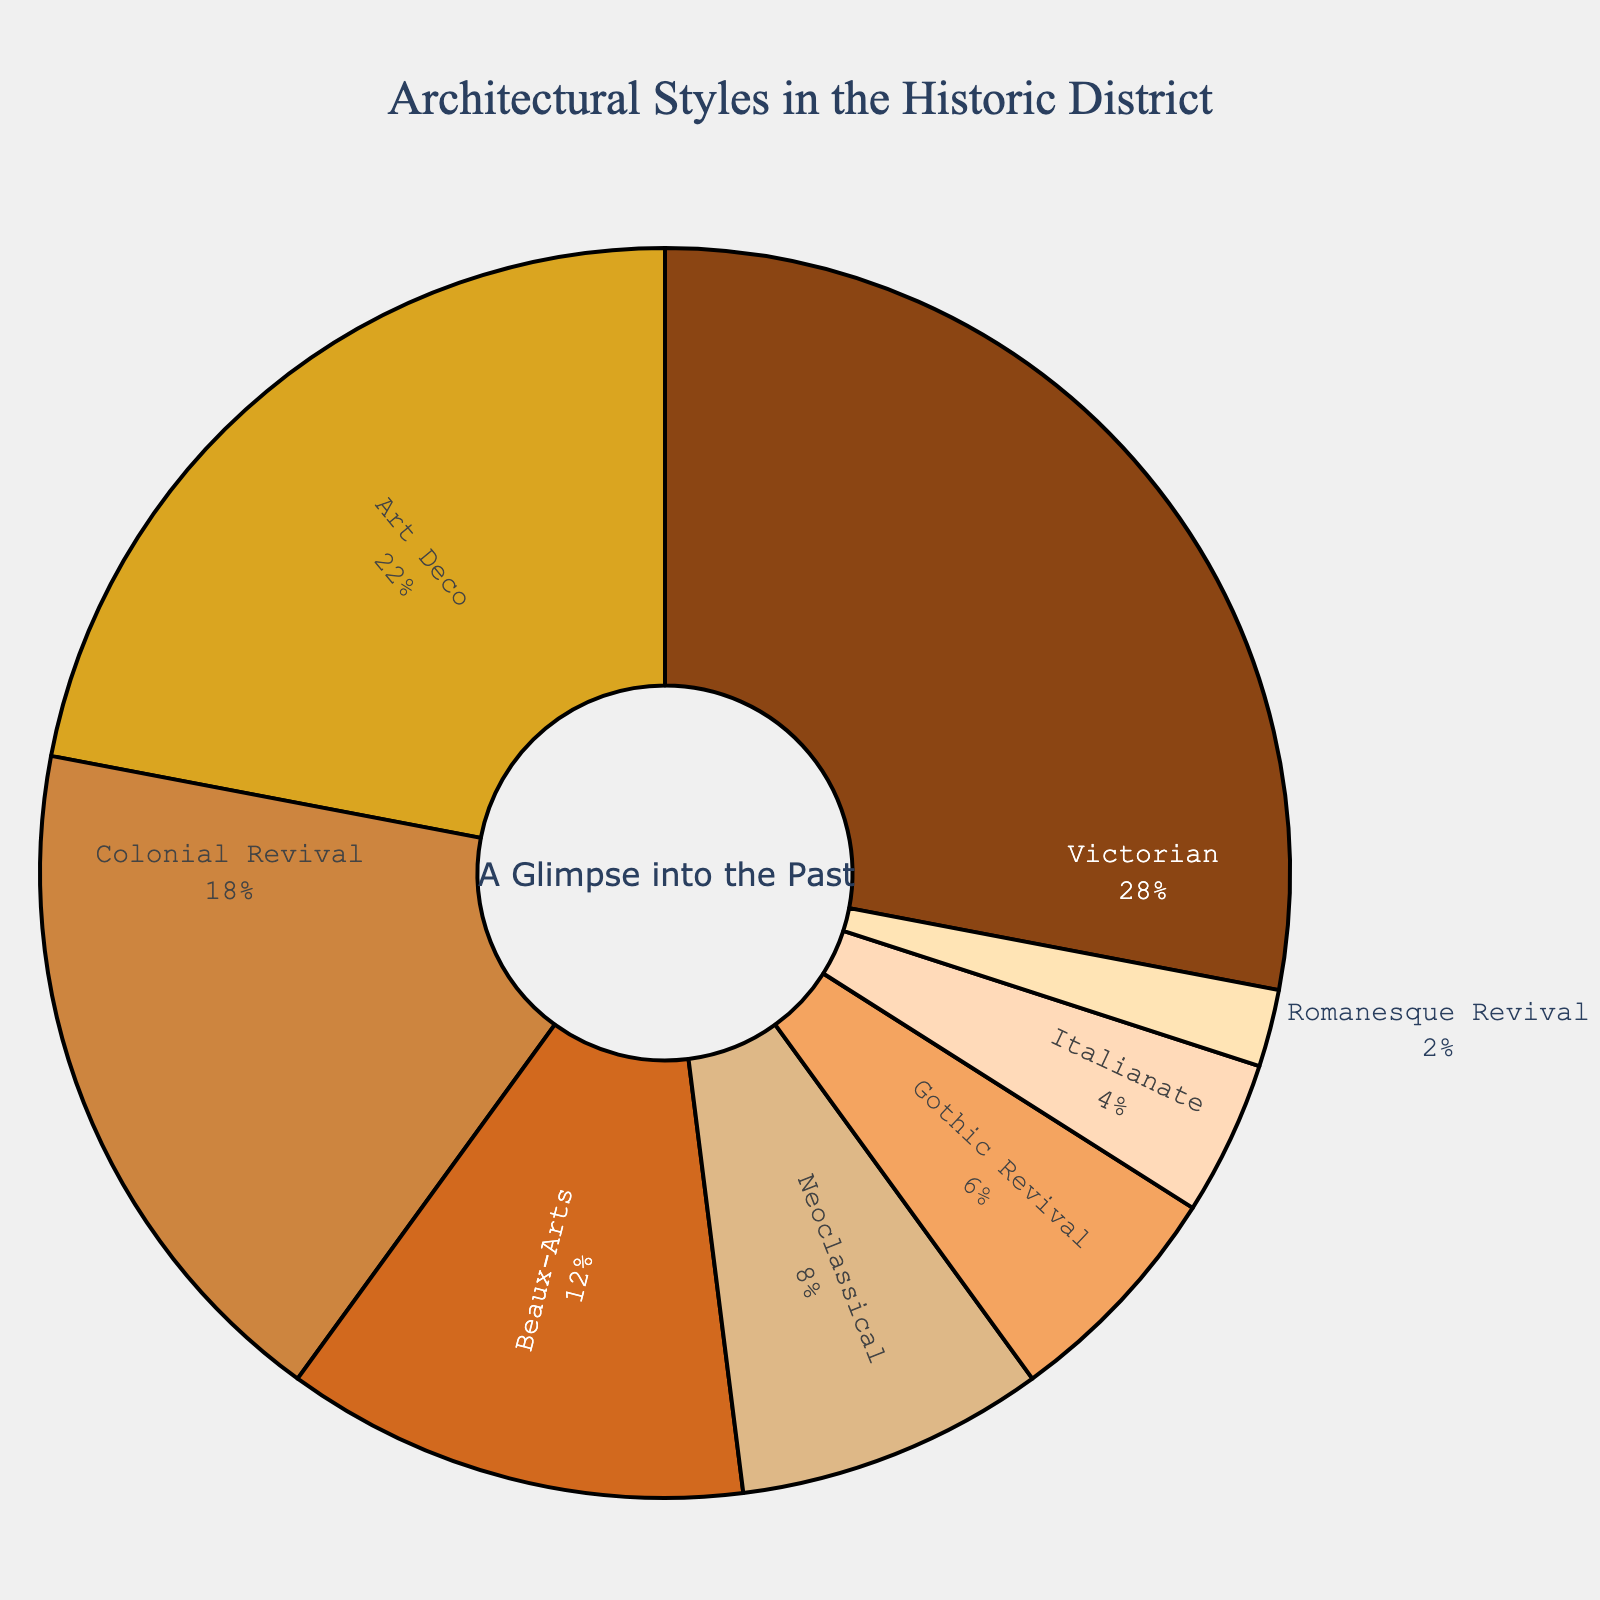Which architectural style has the highest percentage in the historic district? The Victorian style, as indicated by the largest segment of the pie with 28%, has the highest percentage according to the figure.
Answer: Victorian Which two architectural styles combined represent exactly half of the historic district's architectural styles? The Victorian and Art Deco styles combined represent exactly half of the historic district's architectural styles. Victorian is 28% and Art Deco is 22%, summing up to 50%.
Answer: Victorian and Art Deco How much more prevalent is the Victorian style compared to the Gothic Revival style? The Victorian style has a percentage of 28%, while the Gothic Revival style has 6%. The difference is calculated as 28% - 6% = 22%.
Answer: 22% Which architectural style has the smallest representation in the historic district? The Romanesque Revival style has the smallest representation, with only 2%, as indicated by the smallest segment of the pie.
Answer: Romanesque Revival Which three architectural styles have the lowest percentages combined? The Gothic Revival (6%), Italianate (4%), and Romanesque Revival (2%) styles have the lowest percentages. Combined, their total is 6% + 4% + 2% = 12%.
Answer: Gothic Revival, Italianate and Romanesque Revival By how many percentage points does the Art Deco style exceed the Neoclassical style in the historic district? The Art Deco style is at 22%, and the Neoclassical style is at 8%. The difference is 22% - 8% = 14%.
Answer: 14% What is the sum of percentages for the top three most common architectural styles in the historic district? The top three most common styles are Victorian (28%), Art Deco (22%), and Colonial Revival (18%). The sum is 28% + 22% + 18% = 68%.
Answer: 68% Which style comes in third place in terms of percentage presence in the historic district? The third place is occupied by the Colonial Revival style, with a percentage of 18%, as seen in the pie chart.
Answer: Colonial Revival How many architectural styles have a representation equal to or greater than 10% in the historic district? The Victorian (28%), Art Deco (22%), and Colonial Revival (18%) styles all have representations equal to or greater than 10%. In total, there are three styles.
Answer: 3 styles What is the percentage difference between the second largest and the smallest architectural style? The second largest style, Art Deco, is at 22%, and the smallest, Romanesque Revival, is at 2%. The difference is 22% - 2% = 20%.
Answer: 20% 